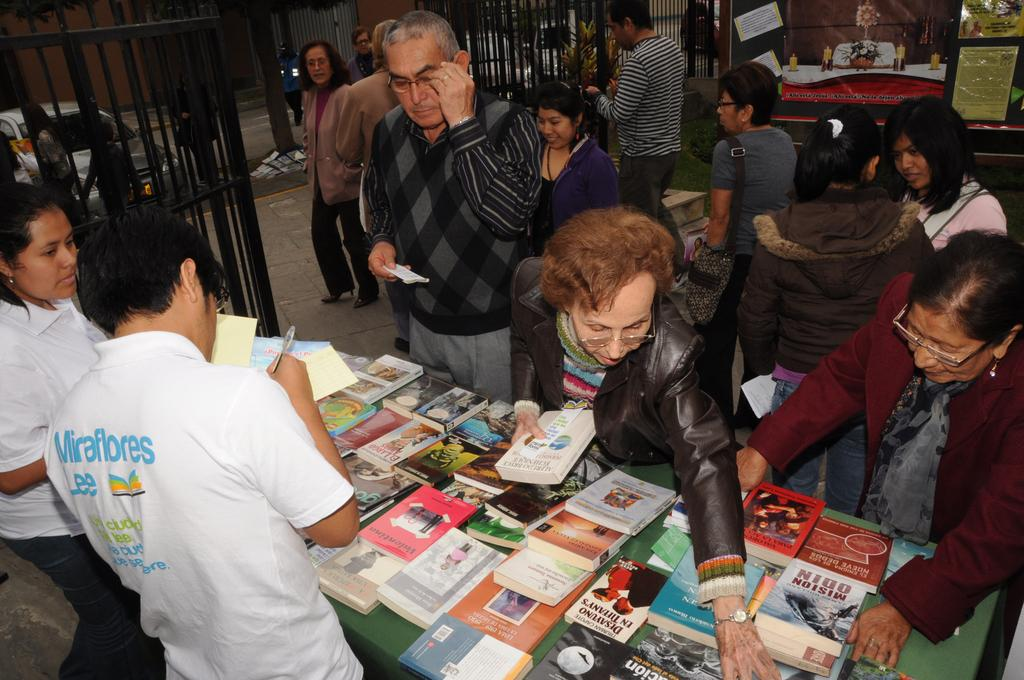<image>
Share a concise interpretation of the image provided. People looking at books laid out on a table and one man has Miraflores on the back of his shirt. 